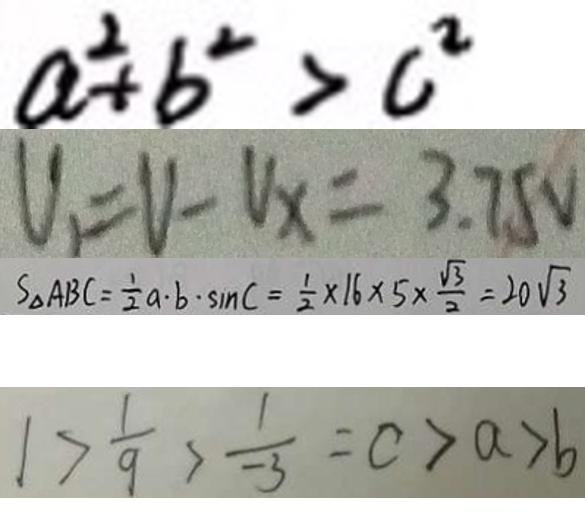Convert formula to latex. <formula><loc_0><loc_0><loc_500><loc_500>a ^ { 2 } + b ^ { 2 } > c ^ { 2 } 
 V _ { 1 } = V - V _ { x } = 3 . 7 5 V 
 S _ { \Delta } A B C = \frac { 1 } { 2 } a \cdot b \cdot \sin C = \frac { 1 } { 2 } \times 1 6 \times 5 \times \frac { \sqrt { 3 } } { 2 } = 2 0 \sqrt { 3 } 
 1 > \frac { 1 } { 9 } > \frac { 1 } { - 3 } = c > a > b</formula> 